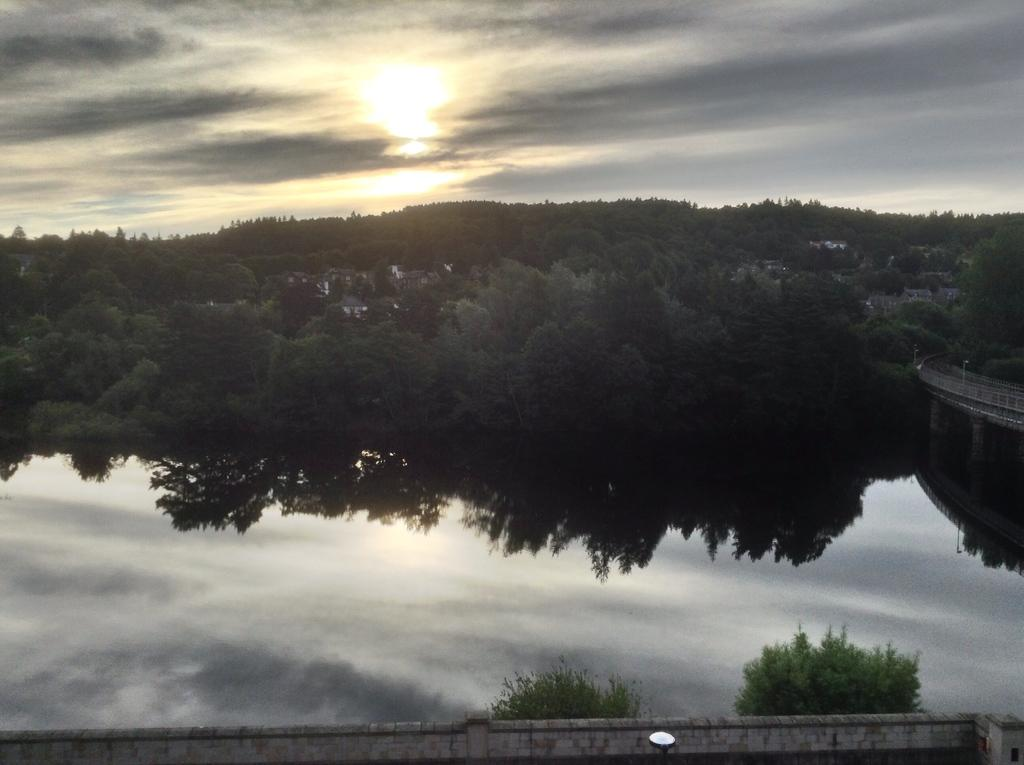What is the primary element visible in the image? There is a water surface in the image. What can be seen behind the water surface? There are trees visible behind the water surface. What else is visible in the image besides the water and trees? The sky is visible in the image. How are the trees and sky represented in the image? The trees and sky are reflected on the water surface. Where is the swing located in the image? There is no swing present in the image. How does the nut expand in the image? There is no nut present in the image, and therefore no expansion can be observed. 